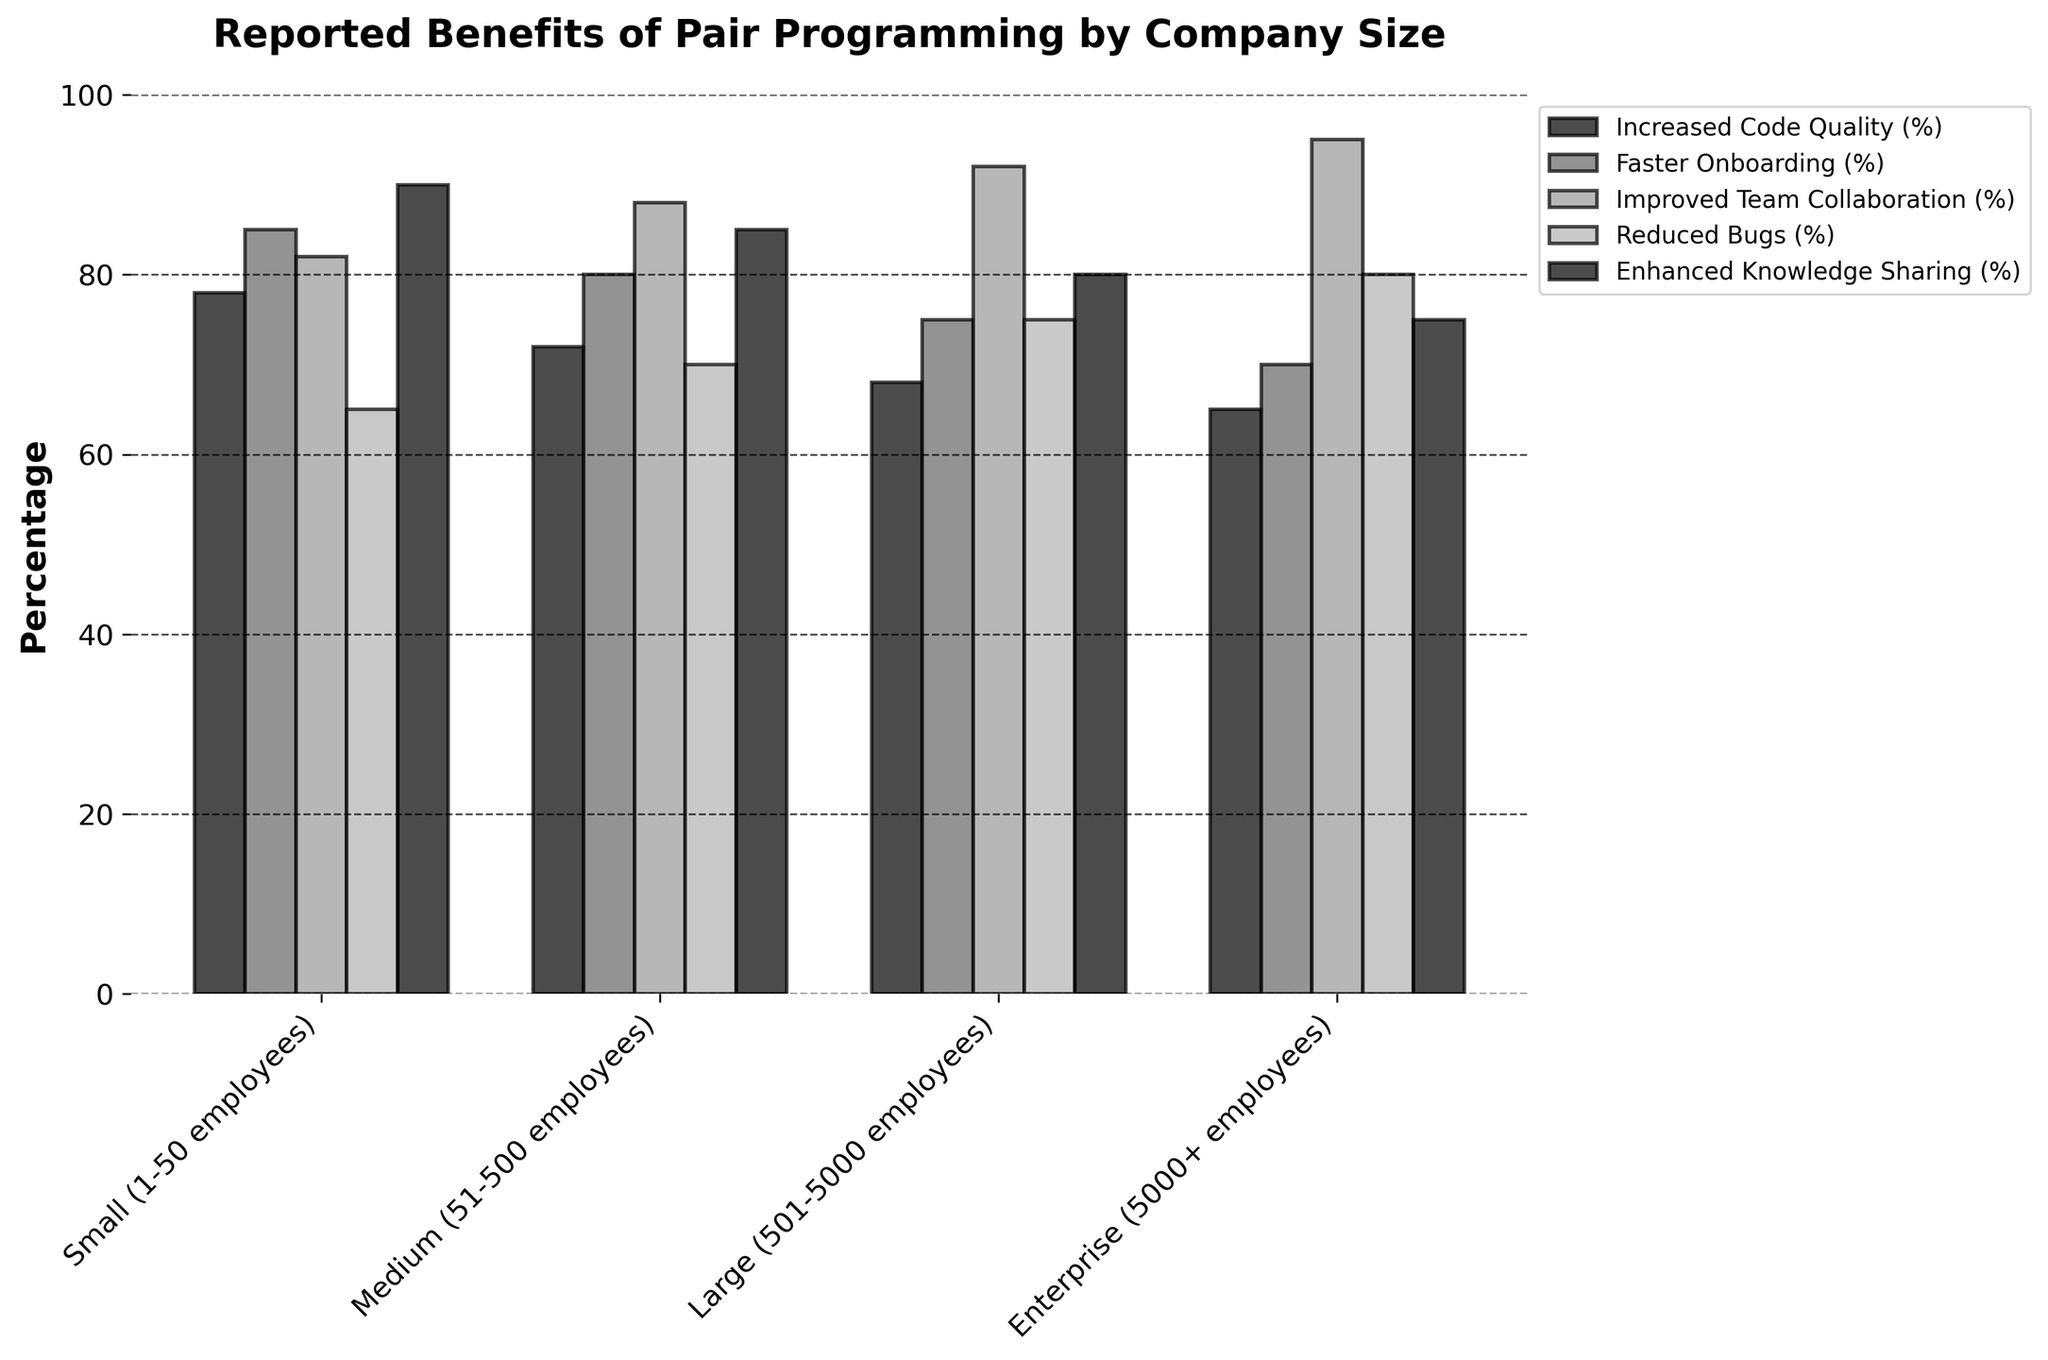Which company size reports the highest percentage of improved team collaboration? Look at the bars for each company size that correspond to 'Improved Team Collaboration (%)'. The 'Enterprise (5000+ employees)' bar is tallest, indicating it has the highest percentage.
Answer: Enterprise (5000+ employees) Which benefit has the lowest percentage for small companies (1-50 employees)? Focus on the bars corresponding to the 'Small (1-50 employees)' company size. The 'Reduced Bugs (%)' bar is shortest, indicating it has the lowest percentage.
Answer: Reduced Bugs How does the percentage of increased code quality compare between small (1-50 employees) and large (501-5000 employees) companies? Compare the 'Increased Code Quality (%)' bars for 'Small (1-50 employees)' and 'Large (501-5000 employees)'. The percentage for small companies is 78%, while for large companies it is 68%.
Answer: Small companies have a higher percentage by 10% What is the average percentage for enhanced knowledge sharing in all company sizes? Calculate the mean of the 'Enhanced Knowledge Sharing (%)' values: (90 + 85 + 80 + 75) / 4 = 330 / 4.
Answer: 82.5% Which two benefits have the same percentage for medium (51-500 employees) companies? Focus on the 'Medium (51-500 employees)' columns and compare the bars for percentages. The 'Increased Code Quality (%)' and 'Enhanced Knowledge Sharing (%)' both have a value of 85%.
Answer: Increased Code Quality and Enhanced Knowledge Sharing For enterprise companies, which benefit shows the second-highest percentage? Look at all the bars for 'Enterprise (5000+ employees)' and identify the highest. 'Improved Team Collaboration (%)' is highest at 95%, followed by 'Reduced Bugs (%)' at 80%.
Answer: Reduced Bugs What is the difference in the percentage of reduced bugs between small (1-50 employees) and enterprise (5000+ employees) companies? Subtract the percentages of 'Reduced Bugs (%)' for 'Small (1-50 employees)' and 'Enterprise (5000+ employees)': 80% - 65%.
Answer: 15% Which benefit has the greatest overall variation in percentage values across different company sizes? Compare the range (maximum - minimum) for each benefit. 'Increased Code Quality (%)' ranges from 78% to 65%, 'Faster Onboarding (%)' from 85% to 70%, 'Improved Team Collaboration (%)' from 95% to 82%, 'Reduced Bugs (%)' from 80% to 65%, and 'Enhanced Knowledge Sharing (%)' from 90% to 75%. 'Improved Team Collaboration (%)' has the greatest range.
Answer: Improved Team Collaboration For large (501-5000 employees) companies, what is the combined percentage for improved team collaboration and reduced bugs? Add the percentages for 'Improved Team Collaboration (%)' (92%) and 'Reduced Bugs (%)' (75%): 92 + 75 = 167%.
Answer: 167% Which company size has the smallest range in percentages across all reported benefits? Calculate the range for each company size. For 'Small (1-50 employees)', range = 90 - 65 = 25. For 'Medium (51-500 employees)', range = 88 - 70 = 18. For 'Large (501-5000 employees)', range = 92 - 68 = 24. For 'Enterprise (5000+ employees)', range = 95 - 65 = 30. Medium companies have the smallest range.
Answer: Medium (51-500 employees) 